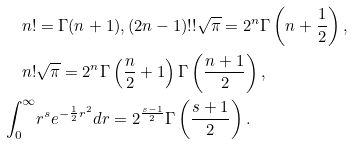<formula> <loc_0><loc_0><loc_500><loc_500>n ! & = \Gamma ( n + 1 ) , ( 2 n - 1 ) ! ! \sqrt { \pi } = 2 ^ { n } \Gamma \left ( n + \frac { 1 } { 2 } \right ) , \\ n ! & \sqrt { \pi } = 2 ^ { n } \Gamma \left ( \frac { n } { 2 } + 1 \right ) \Gamma \left ( \frac { n + 1 } { 2 } \right ) , \\ \int _ { 0 } ^ { \infty } & r ^ { s } e ^ { - \frac { 1 } { 2 } r ^ { 2 } } d r = 2 ^ { \frac { s - 1 } { 2 } } \Gamma \left ( \frac { s + 1 } { 2 } \right ) .</formula> 